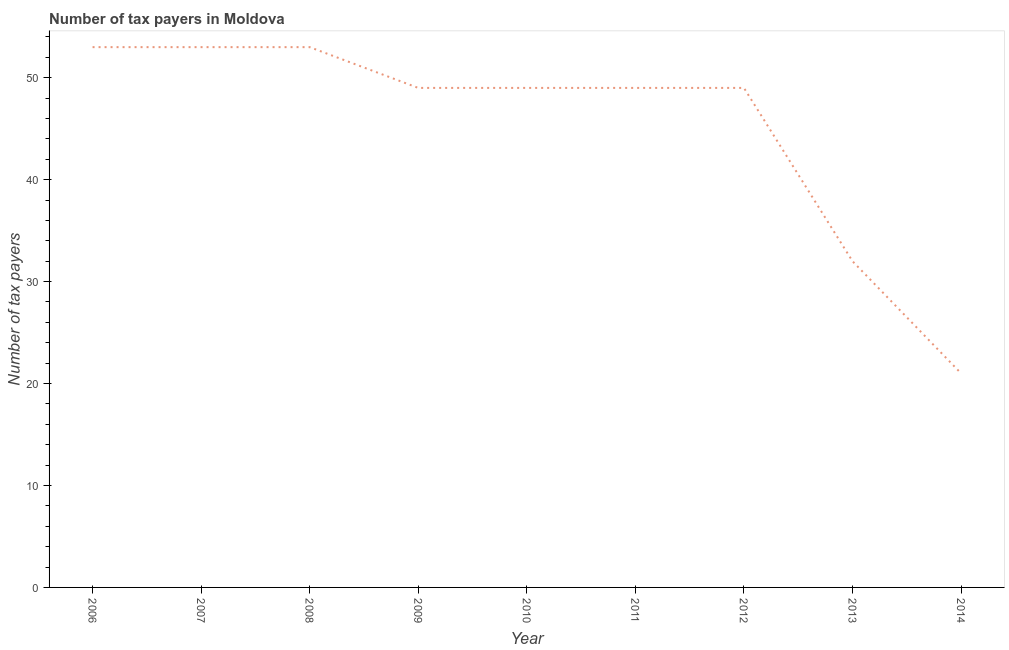What is the number of tax payers in 2006?
Offer a very short reply. 53. Across all years, what is the maximum number of tax payers?
Keep it short and to the point. 53. Across all years, what is the minimum number of tax payers?
Your answer should be very brief. 21. What is the sum of the number of tax payers?
Your answer should be compact. 408. What is the average number of tax payers per year?
Ensure brevity in your answer.  45.33. In how many years, is the number of tax payers greater than 48 ?
Offer a very short reply. 7. Do a majority of the years between 2006 and 2012 (inclusive) have number of tax payers greater than 48 ?
Provide a succinct answer. Yes. What is the ratio of the number of tax payers in 2011 to that in 2013?
Give a very brief answer. 1.53. What is the difference between the highest and the second highest number of tax payers?
Offer a very short reply. 0. Is the sum of the number of tax payers in 2010 and 2014 greater than the maximum number of tax payers across all years?
Keep it short and to the point. Yes. What is the difference between the highest and the lowest number of tax payers?
Make the answer very short. 32. How many lines are there?
Your answer should be very brief. 1. What is the difference between two consecutive major ticks on the Y-axis?
Your answer should be compact. 10. Are the values on the major ticks of Y-axis written in scientific E-notation?
Your answer should be very brief. No. Does the graph contain any zero values?
Give a very brief answer. No. Does the graph contain grids?
Provide a succinct answer. No. What is the title of the graph?
Provide a succinct answer. Number of tax payers in Moldova. What is the label or title of the Y-axis?
Your answer should be very brief. Number of tax payers. What is the Number of tax payers in 2006?
Provide a short and direct response. 53. What is the Number of tax payers in 2007?
Give a very brief answer. 53. What is the Number of tax payers of 2008?
Ensure brevity in your answer.  53. What is the Number of tax payers in 2011?
Give a very brief answer. 49. What is the Number of tax payers of 2012?
Offer a very short reply. 49. What is the Number of tax payers in 2013?
Your response must be concise. 32. What is the Number of tax payers of 2014?
Your answer should be very brief. 21. What is the difference between the Number of tax payers in 2006 and 2007?
Offer a very short reply. 0. What is the difference between the Number of tax payers in 2006 and 2009?
Ensure brevity in your answer.  4. What is the difference between the Number of tax payers in 2006 and 2011?
Your answer should be very brief. 4. What is the difference between the Number of tax payers in 2007 and 2008?
Give a very brief answer. 0. What is the difference between the Number of tax payers in 2007 and 2010?
Give a very brief answer. 4. What is the difference between the Number of tax payers in 2008 and 2013?
Make the answer very short. 21. What is the difference between the Number of tax payers in 2009 and 2010?
Your answer should be very brief. 0. What is the difference between the Number of tax payers in 2009 and 2012?
Make the answer very short. 0. What is the difference between the Number of tax payers in 2009 and 2013?
Make the answer very short. 17. What is the difference between the Number of tax payers in 2009 and 2014?
Your response must be concise. 28. What is the difference between the Number of tax payers in 2010 and 2011?
Give a very brief answer. 0. What is the difference between the Number of tax payers in 2010 and 2012?
Offer a very short reply. 0. What is the difference between the Number of tax payers in 2010 and 2013?
Keep it short and to the point. 17. What is the difference between the Number of tax payers in 2010 and 2014?
Your answer should be very brief. 28. What is the difference between the Number of tax payers in 2011 and 2012?
Give a very brief answer. 0. What is the difference between the Number of tax payers in 2011 and 2013?
Offer a very short reply. 17. What is the difference between the Number of tax payers in 2011 and 2014?
Make the answer very short. 28. What is the difference between the Number of tax payers in 2012 and 2013?
Your response must be concise. 17. What is the difference between the Number of tax payers in 2012 and 2014?
Keep it short and to the point. 28. What is the ratio of the Number of tax payers in 2006 to that in 2007?
Provide a short and direct response. 1. What is the ratio of the Number of tax payers in 2006 to that in 2008?
Your response must be concise. 1. What is the ratio of the Number of tax payers in 2006 to that in 2009?
Your response must be concise. 1.08. What is the ratio of the Number of tax payers in 2006 to that in 2010?
Your response must be concise. 1.08. What is the ratio of the Number of tax payers in 2006 to that in 2011?
Ensure brevity in your answer.  1.08. What is the ratio of the Number of tax payers in 2006 to that in 2012?
Provide a succinct answer. 1.08. What is the ratio of the Number of tax payers in 2006 to that in 2013?
Keep it short and to the point. 1.66. What is the ratio of the Number of tax payers in 2006 to that in 2014?
Offer a very short reply. 2.52. What is the ratio of the Number of tax payers in 2007 to that in 2008?
Provide a succinct answer. 1. What is the ratio of the Number of tax payers in 2007 to that in 2009?
Offer a terse response. 1.08. What is the ratio of the Number of tax payers in 2007 to that in 2010?
Your answer should be very brief. 1.08. What is the ratio of the Number of tax payers in 2007 to that in 2011?
Ensure brevity in your answer.  1.08. What is the ratio of the Number of tax payers in 2007 to that in 2012?
Offer a terse response. 1.08. What is the ratio of the Number of tax payers in 2007 to that in 2013?
Provide a succinct answer. 1.66. What is the ratio of the Number of tax payers in 2007 to that in 2014?
Offer a terse response. 2.52. What is the ratio of the Number of tax payers in 2008 to that in 2009?
Offer a terse response. 1.08. What is the ratio of the Number of tax payers in 2008 to that in 2010?
Keep it short and to the point. 1.08. What is the ratio of the Number of tax payers in 2008 to that in 2011?
Your answer should be very brief. 1.08. What is the ratio of the Number of tax payers in 2008 to that in 2012?
Offer a terse response. 1.08. What is the ratio of the Number of tax payers in 2008 to that in 2013?
Ensure brevity in your answer.  1.66. What is the ratio of the Number of tax payers in 2008 to that in 2014?
Ensure brevity in your answer.  2.52. What is the ratio of the Number of tax payers in 2009 to that in 2010?
Make the answer very short. 1. What is the ratio of the Number of tax payers in 2009 to that in 2012?
Your response must be concise. 1. What is the ratio of the Number of tax payers in 2009 to that in 2013?
Provide a short and direct response. 1.53. What is the ratio of the Number of tax payers in 2009 to that in 2014?
Your answer should be compact. 2.33. What is the ratio of the Number of tax payers in 2010 to that in 2013?
Offer a terse response. 1.53. What is the ratio of the Number of tax payers in 2010 to that in 2014?
Keep it short and to the point. 2.33. What is the ratio of the Number of tax payers in 2011 to that in 2012?
Provide a short and direct response. 1. What is the ratio of the Number of tax payers in 2011 to that in 2013?
Keep it short and to the point. 1.53. What is the ratio of the Number of tax payers in 2011 to that in 2014?
Give a very brief answer. 2.33. What is the ratio of the Number of tax payers in 2012 to that in 2013?
Provide a short and direct response. 1.53. What is the ratio of the Number of tax payers in 2012 to that in 2014?
Provide a succinct answer. 2.33. What is the ratio of the Number of tax payers in 2013 to that in 2014?
Provide a succinct answer. 1.52. 